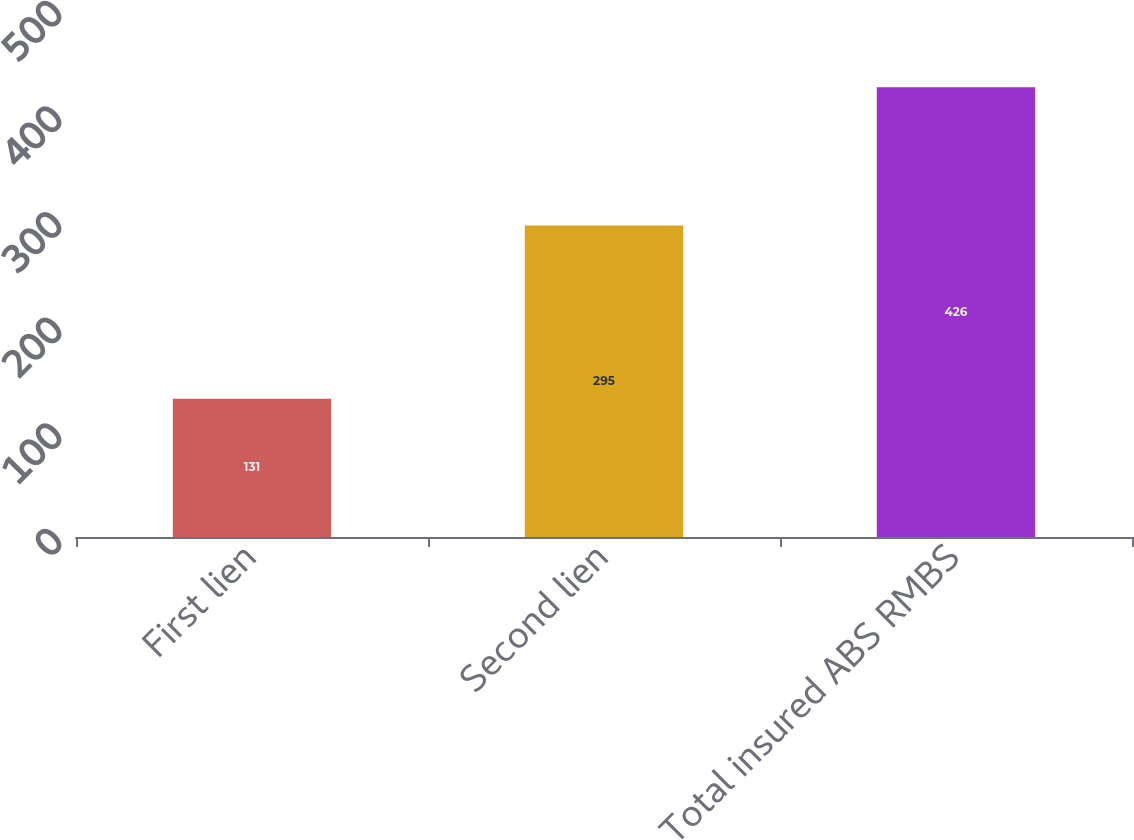<chart> <loc_0><loc_0><loc_500><loc_500><bar_chart><fcel>First lien<fcel>Second lien<fcel>Total insured ABS RMBS<nl><fcel>131<fcel>295<fcel>426<nl></chart> 